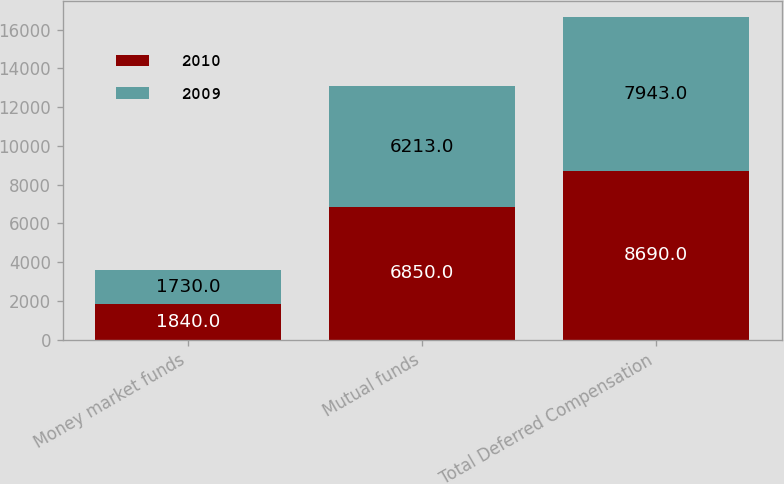<chart> <loc_0><loc_0><loc_500><loc_500><stacked_bar_chart><ecel><fcel>Money market funds<fcel>Mutual funds<fcel>Total Deferred Compensation<nl><fcel>2010<fcel>1840<fcel>6850<fcel>8690<nl><fcel>2009<fcel>1730<fcel>6213<fcel>7943<nl></chart> 